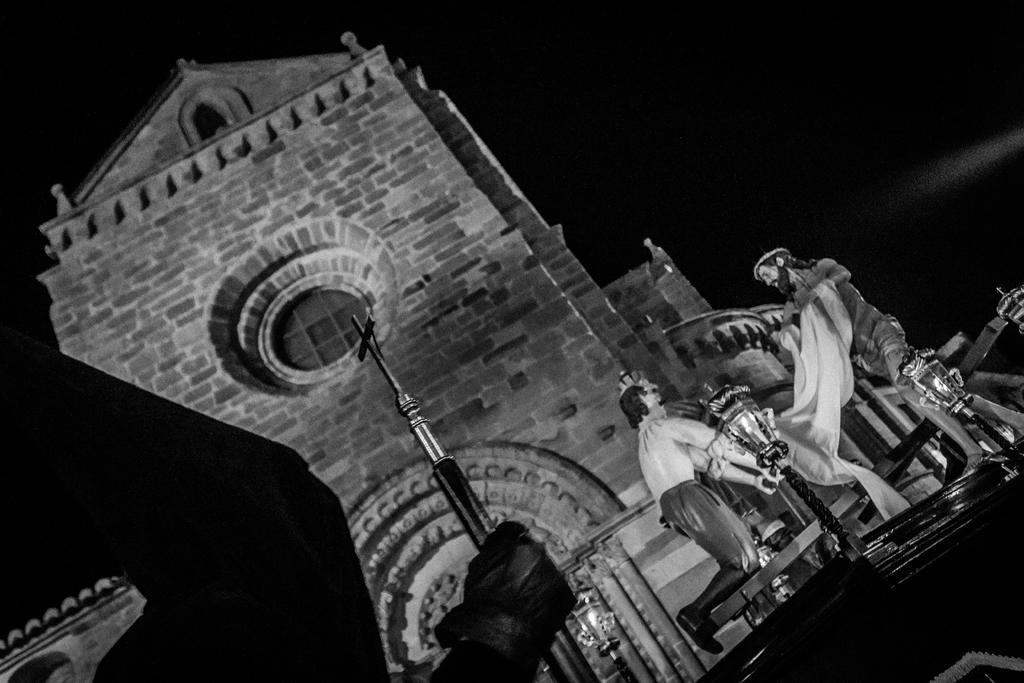Can you describe this image briefly? It is a black and white image. In this image we can see the outside view of the church. We can also see the depictions of persons. Lights are also visible in this image. 